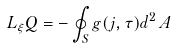<formula> <loc_0><loc_0><loc_500><loc_500>L _ { \xi } Q = - \oint _ { S } g ( j , \tau ) d ^ { 2 } \, A</formula> 